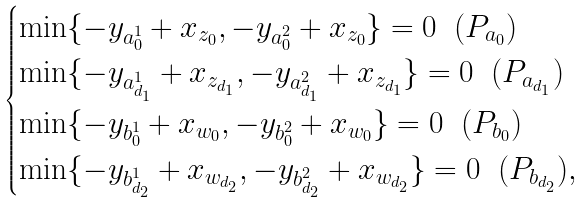Convert formula to latex. <formula><loc_0><loc_0><loc_500><loc_500>\begin{cases} \min \{ - y _ { a _ { 0 } ^ { 1 } } + x _ { z _ { 0 } } , - y _ { a _ { 0 } ^ { 2 } } + x _ { z _ { 0 } } \} = 0 \ \ ( P _ { a _ { 0 } } ) \\ \min \{ - y _ { a _ { d _ { 1 } } ^ { 1 } } + x _ { z _ { d _ { 1 } } } , - y _ { a _ { d _ { 1 } } ^ { 2 } } + x _ { z _ { d _ { 1 } } } \} = 0 \ \ ( P _ { a _ { d _ { 1 } } } ) \\ \min \{ - y _ { b _ { 0 } ^ { 1 } } + x _ { w _ { 0 } } , - y _ { b _ { 0 } ^ { 2 } } + x _ { w _ { 0 } } \} = 0 \ \ ( P _ { b _ { 0 } } ) \\ \min \{ - y _ { b _ { d _ { 2 } } ^ { 1 } } + x _ { w _ { d _ { 2 } } } , - y _ { b _ { d _ { 2 } } ^ { 2 } } + x _ { w _ { d _ { 2 } } } \} = 0 \ \ ( P _ { b _ { d _ { 2 } } } ) , \end{cases}</formula> 